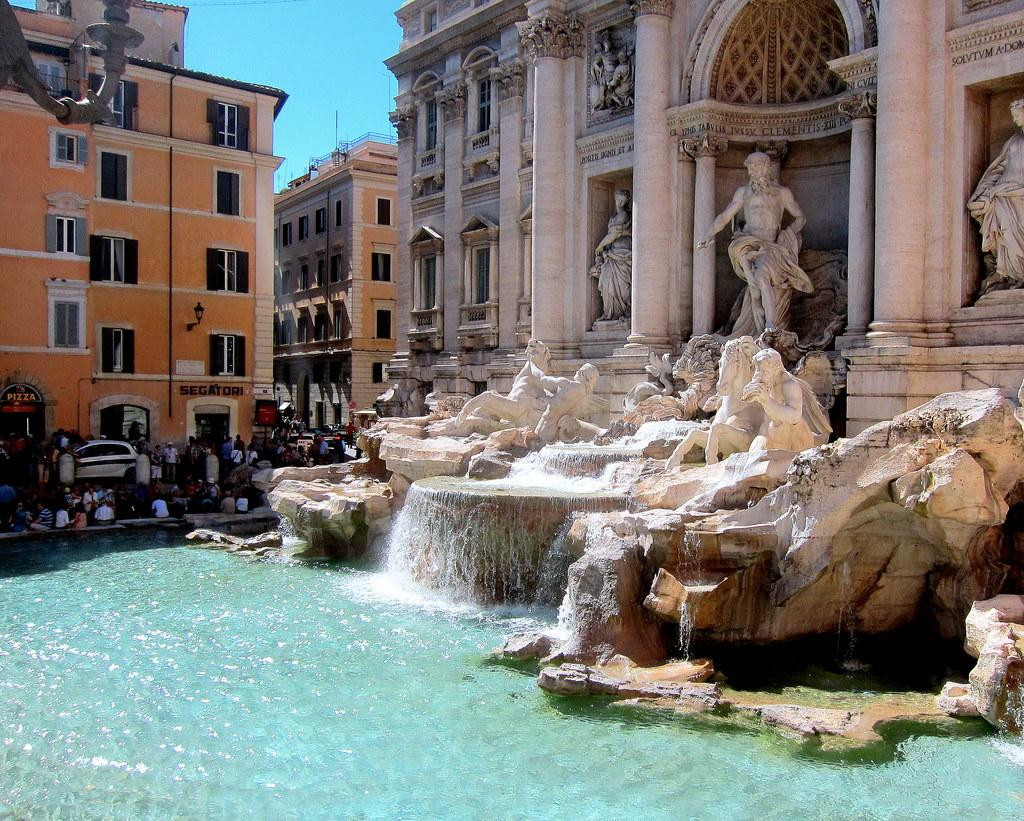What is the primary element present in the image? The image contains water. What type of artistic objects can be seen in the image? There are sculptures in the image. Is there any transportation visible in the image? Yes, there is a car in the image. Can you describe the people in the image? There is a group of people in the image. What can be seen in the distance in the image? There are buildings in the background of the image, and the sky is visible in the background as well. What type of honey is being used to teach the group of people in the image? There is no honey or teaching activity present in the image. 